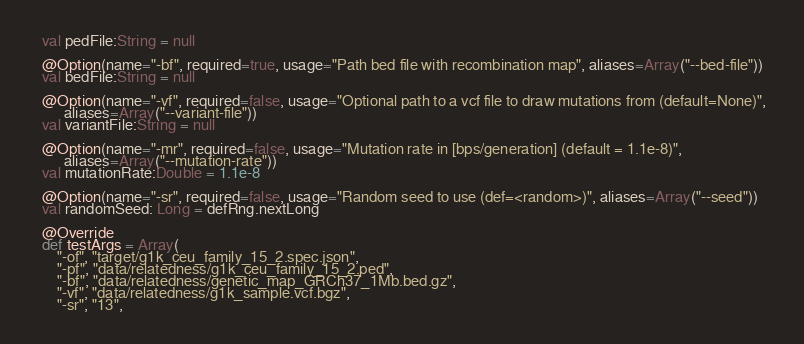Convert code to text. <code><loc_0><loc_0><loc_500><loc_500><_Scala_>  val pedFile:String = null

  @Option(name="-bf", required=true, usage="Path bed file with recombination map", aliases=Array("--bed-file"))
  val bedFile:String = null
  
  @Option(name="-vf", required=false, usage="Optional path to a vcf file to draw mutations from (default=None)", 
        aliases=Array("--variant-file"))
  val variantFile:String = null

  @Option(name="-mr", required=false, usage="Mutation rate in [bps/generation] (default = 1.1e-8)", 
        aliases=Array("--mutation-rate"))
  val mutationRate:Double = 1.1e-8

  @Option(name="-sr", required=false, usage="Random seed to use (def=<random>)", aliases=Array("--seed"))
  val randomSeed: Long = defRng.nextLong

  @Override
  def testArgs = Array(
      "-of", "target/g1k_ceu_family_15_2.spec.json",
      "-pf", "data/relatedness/g1k_ceu_family_15_2.ped", 
      "-bf", "data/relatedness/genetic_map_GRCh37_1Mb.bed.gz",
      "-vf", "data/relatedness/g1k_sample.vcf.bgz",
      "-sr", "13", </code> 